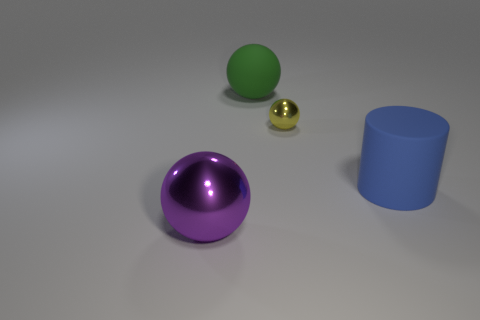Is the number of large purple spheres to the right of the small metal ball less than the number of small red metal spheres?
Offer a terse response. No. What shape is the small object?
Offer a very short reply. Sphere. How big is the rubber object behind the big blue cylinder?
Provide a short and direct response. Large. There is a shiny sphere that is the same size as the green thing; what is its color?
Make the answer very short. Purple. Is the number of big green matte things left of the large green matte sphere less than the number of spheres left of the yellow object?
Provide a succinct answer. Yes. The thing that is both to the left of the yellow ball and in front of the tiny object is made of what material?
Offer a terse response. Metal. Is the shape of the small yellow thing the same as the metallic object that is in front of the small sphere?
Make the answer very short. Yes. How many other things are there of the same size as the green rubber object?
Offer a terse response. 2. Is the number of green things greater than the number of large rubber objects?
Make the answer very short. No. What number of balls are left of the tiny metal object and right of the large metallic sphere?
Your response must be concise. 1. 